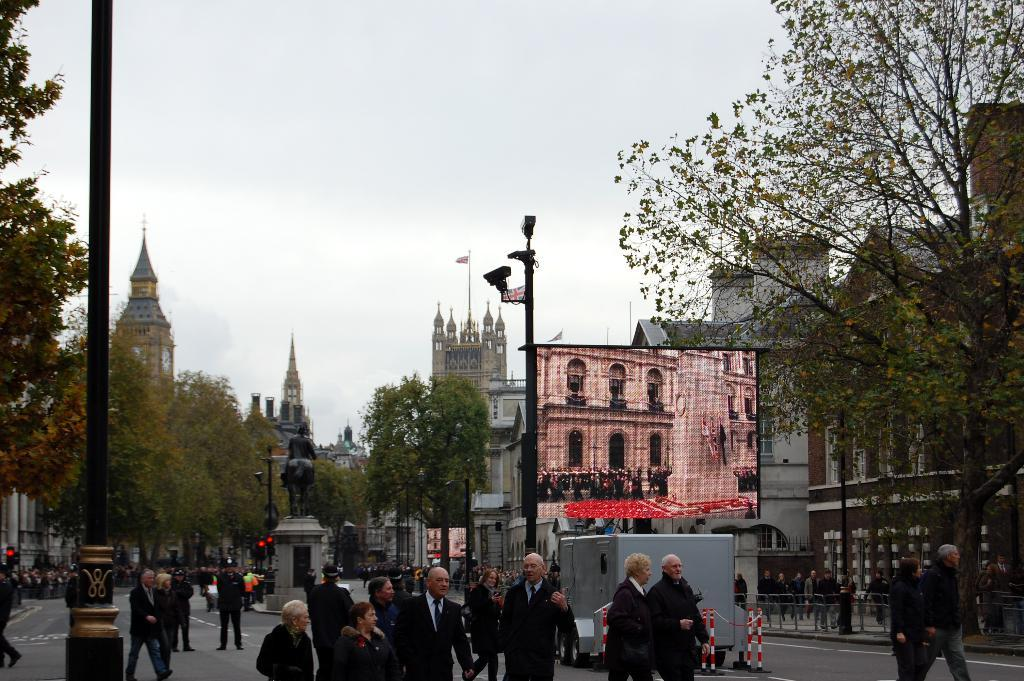What can be seen in the image involving people? There are people standing in the image. What objects are present in the image that are related to traffic or transportation? Poles, signal lights, and a vehicle are present in the image. What type of natural elements can be seen in the image? Trees are visible in the image. What type of structures are present in the image? Buildings are present in the image. What part of the environment is visible in the image? The sky is visible in the image. What type of leather is being used to make the cord visible in the image? There is no leather or cord present in the image. What color is the beetle crawling on the pole in the image? There is no beetle present in the image. 